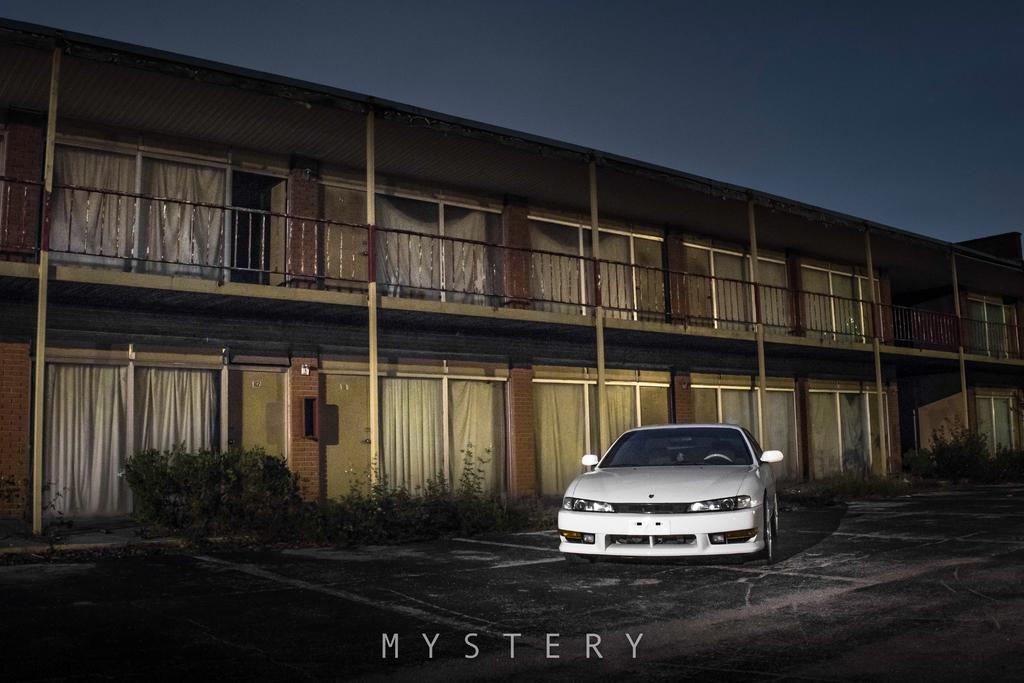Describe this image in one or two sentences. This image is taken during night time. In this image we can see the building. We can also see a car on the path. Image also consists of plants. At the top there is sky and at the bottom we can see the text. 